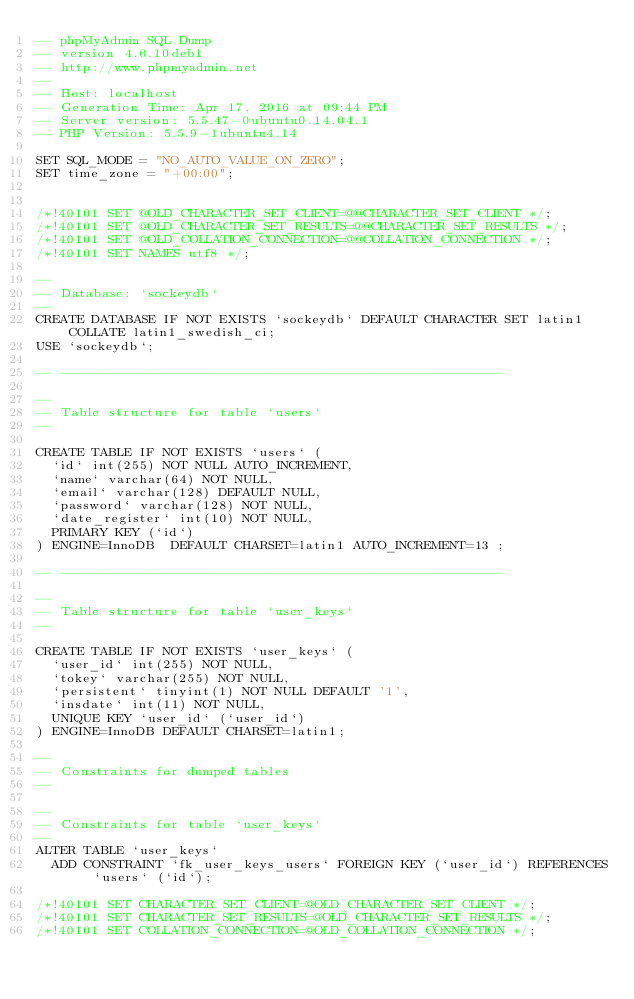Convert code to text. <code><loc_0><loc_0><loc_500><loc_500><_SQL_>-- phpMyAdmin SQL Dump
-- version 4.0.10deb1
-- http://www.phpmyadmin.net
--
-- Host: localhost
-- Generation Time: Apr 17, 2016 at 09:44 PM
-- Server version: 5.5.47-0ubuntu0.14.04.1
-- PHP Version: 5.5.9-1ubuntu4.14

SET SQL_MODE = "NO_AUTO_VALUE_ON_ZERO";
SET time_zone = "+00:00";


/*!40101 SET @OLD_CHARACTER_SET_CLIENT=@@CHARACTER_SET_CLIENT */;
/*!40101 SET @OLD_CHARACTER_SET_RESULTS=@@CHARACTER_SET_RESULTS */;
/*!40101 SET @OLD_COLLATION_CONNECTION=@@COLLATION_CONNECTION */;
/*!40101 SET NAMES utf8 */;

--
-- Database: `sockeydb`
--
CREATE DATABASE IF NOT EXISTS `sockeydb` DEFAULT CHARACTER SET latin1 COLLATE latin1_swedish_ci;
USE `sockeydb`;

-- --------------------------------------------------------

--
-- Table structure for table `users`
--

CREATE TABLE IF NOT EXISTS `users` (
  `id` int(255) NOT NULL AUTO_INCREMENT,
  `name` varchar(64) NOT NULL,
  `email` varchar(128) DEFAULT NULL,
  `password` varchar(128) NOT NULL,
  `date_register` int(10) NOT NULL,
  PRIMARY KEY (`id`)
) ENGINE=InnoDB  DEFAULT CHARSET=latin1 AUTO_INCREMENT=13 ;

-- --------------------------------------------------------

--
-- Table structure for table `user_keys`
--

CREATE TABLE IF NOT EXISTS `user_keys` (
  `user_id` int(255) NOT NULL,
  `tokey` varchar(255) NOT NULL,
  `persistent` tinyint(1) NOT NULL DEFAULT '1',
  `insdate` int(11) NOT NULL,
  UNIQUE KEY `user_id` (`user_id`)
) ENGINE=InnoDB DEFAULT CHARSET=latin1;

--
-- Constraints for dumped tables
--

--
-- Constraints for table `user_keys`
--
ALTER TABLE `user_keys`
  ADD CONSTRAINT `fk_user_keys_users` FOREIGN KEY (`user_id`) REFERENCES `users` (`id`);

/*!40101 SET CHARACTER_SET_CLIENT=@OLD_CHARACTER_SET_CLIENT */;
/*!40101 SET CHARACTER_SET_RESULTS=@OLD_CHARACTER_SET_RESULTS */;
/*!40101 SET COLLATION_CONNECTION=@OLD_COLLATION_CONNECTION */;
</code> 